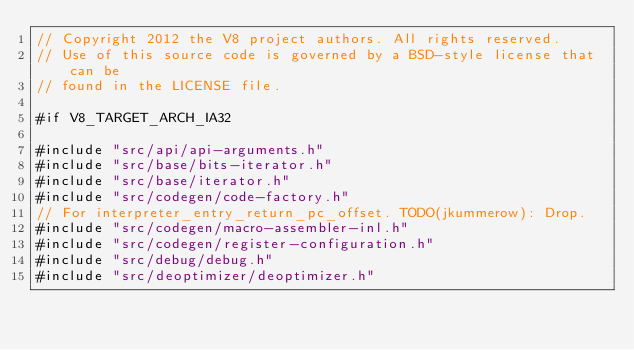<code> <loc_0><loc_0><loc_500><loc_500><_C++_>// Copyright 2012 the V8 project authors. All rights reserved.
// Use of this source code is governed by a BSD-style license that can be
// found in the LICENSE file.

#if V8_TARGET_ARCH_IA32

#include "src/api/api-arguments.h"
#include "src/base/bits-iterator.h"
#include "src/base/iterator.h"
#include "src/codegen/code-factory.h"
// For interpreter_entry_return_pc_offset. TODO(jkummerow): Drop.
#include "src/codegen/macro-assembler-inl.h"
#include "src/codegen/register-configuration.h"
#include "src/debug/debug.h"
#include "src/deoptimizer/deoptimizer.h"</code> 